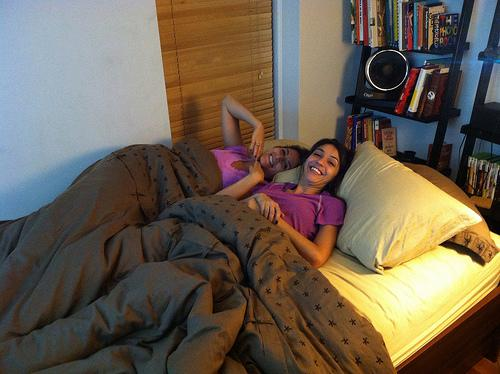Question: where are the people?
Choices:
A. In bed.
B. At a restaurant.
C. On the street.
D. At a bus depot.
Answer with the letter. Answer: A Question: when was the photo taken?
Choices:
A. In the morning.
B. At noon.
C. In the evening.
D. At midnight.
Answer with the letter. Answer: C Question: what is shining?
Choices:
A. A star.
B. A light.
C. A flashlight.
D. A planet.
Answer with the letter. Answer: B Question: who is on the bed?
Choices:
A. The girl.
B. The boy.
C. Two people.
D. The couple.
Answer with the letter. Answer: C 